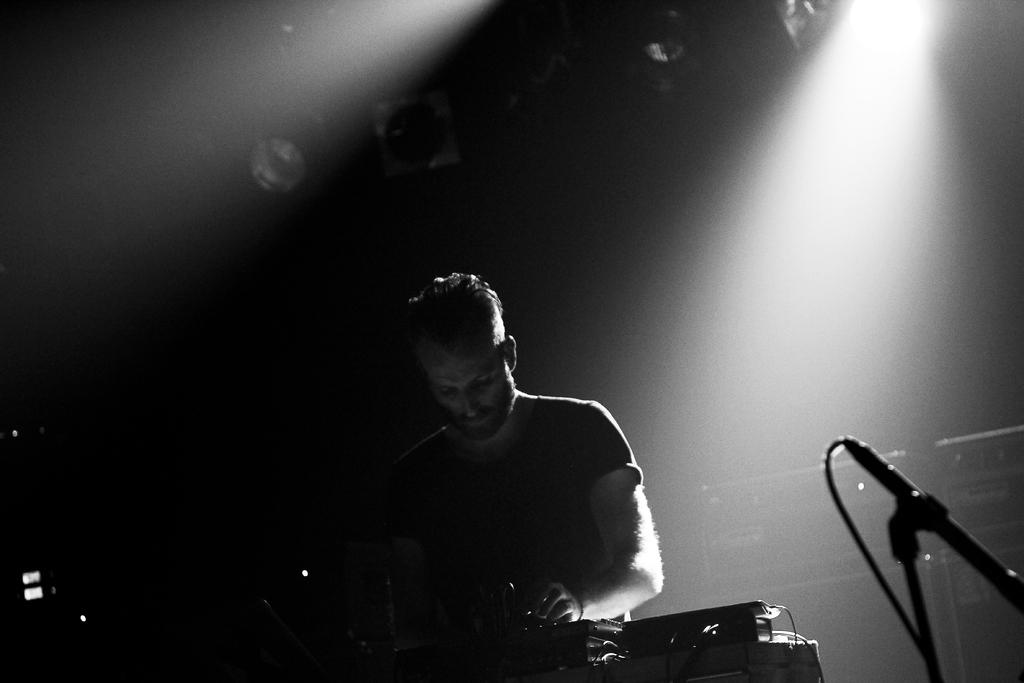What is the person in the image doing? The person is playing a musical instrument. What object is present that might be used for amplifying the person's voice? There is a microphone in the image. What can be seen in the background of the image? There are lights visible in the background, and the background has a dark color. Can you describe the setting where the image might have been taken? The image may have been taken on a stage, given the presence of a microphone and lights. What type of square object can be seen on the person's elbow in the image? There is no square object visible on the person's elbow in the image. What book is the person reading in the image? There is no book or reading activity present in the image; the person is playing a musical instrument. 